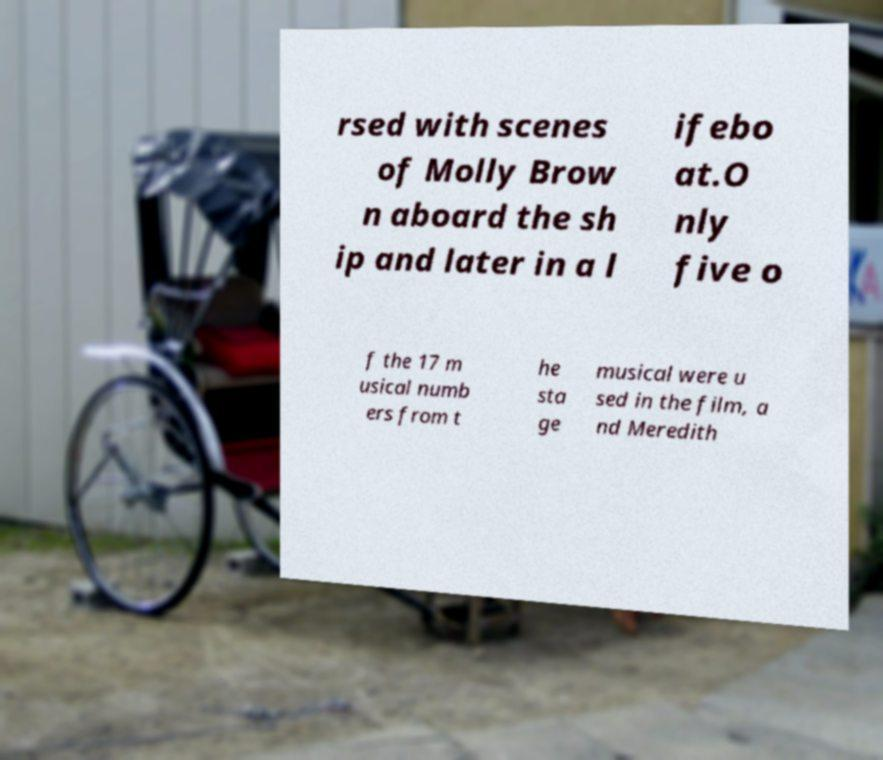Can you read and provide the text displayed in the image?This photo seems to have some interesting text. Can you extract and type it out for me? rsed with scenes of Molly Brow n aboard the sh ip and later in a l ifebo at.O nly five o f the 17 m usical numb ers from t he sta ge musical were u sed in the film, a nd Meredith 